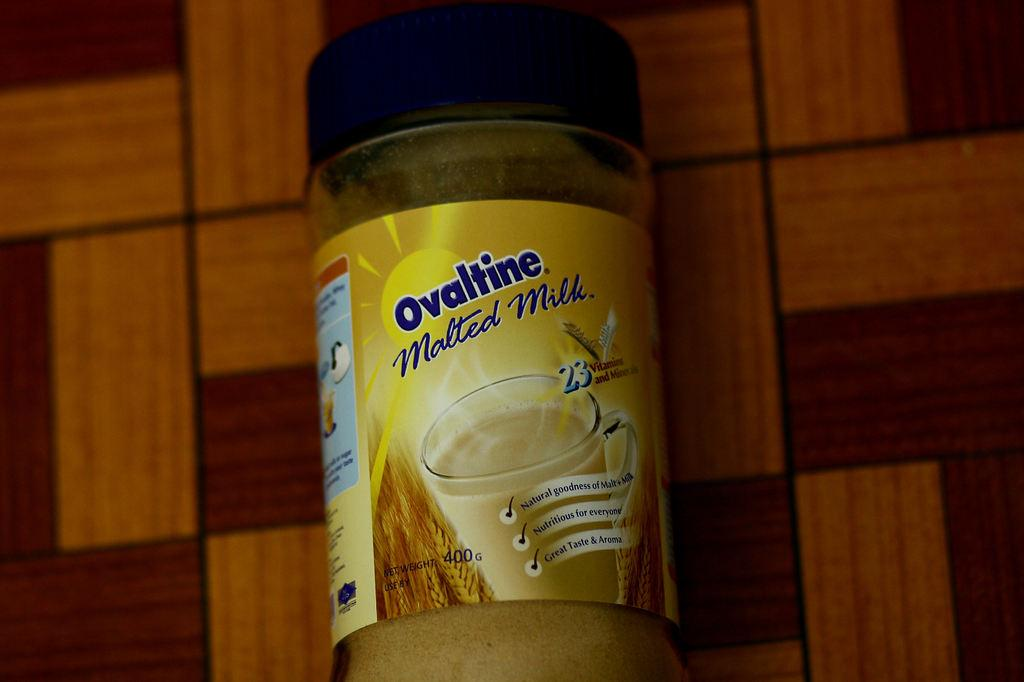<image>
Give a short and clear explanation of the subsequent image. A jar of Ovaltine Metled Milk filled with yellow substance. 